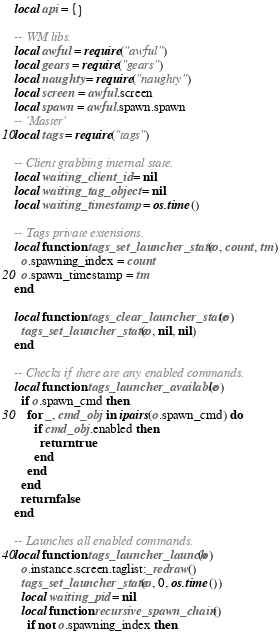Convert code to text. <code><loc_0><loc_0><loc_500><loc_500><_Lua_>local api = {}

-- WM libs.
local awful = require("awful")
local gears = require("gears")
local naughty = require("naughty")
local screen = awful.screen
local spawn = awful.spawn.spawn
-- 'Master'
local tags = require("tags")

-- Client grabbing internal state.
local waiting_client_id = nil
local waiting_tag_object = nil
local waiting_timestamp = os.time()

-- Tags private extensions.
local function tags_set_launcher_state(o, count, tm)
  o.spawning_index = count
  o.spawn_timestamp = tm
end

local function tags_clear_launcher_state(o)
  tags_set_launcher_state(o, nil, nil)
end

-- Checks if there are any enabled commands.
local function tags_launcher_available(o)
  if o.spawn_cmd then
    for _, cmd_obj in ipairs(o.spawn_cmd) do
      if cmd_obj.enabled then
        return true
      end
    end
  end
  return false
end

-- Launches all enabled commands.
local function tags_launcher_launch(o)
  o.instance.screen.taglist:_redraw()
  tags_set_launcher_state(o, 0, os.time())
  local waiting_pid = nil
  local function recursive_spawn_chain()
    if not o.spawning_index then</code> 